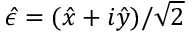<formula> <loc_0><loc_0><loc_500><loc_500>\hat { \epsilon } = ( \hat { x } + i \hat { y } ) / \sqrt { 2 }</formula> 